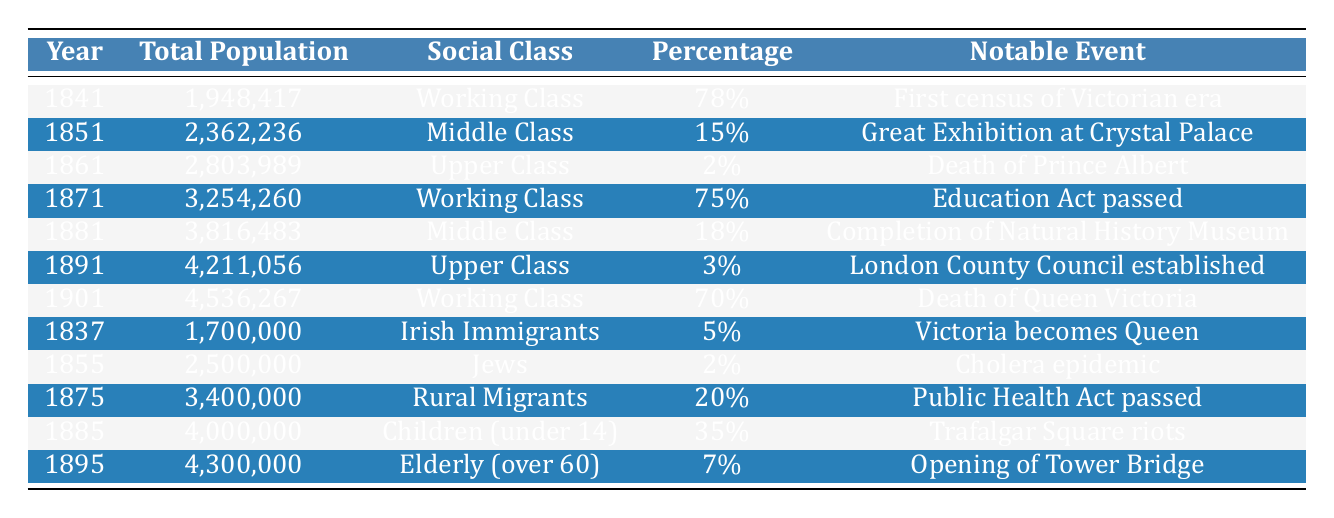What year had the highest total population in London? By inspecting the total population column, the highest value is 4,536,267, which corresponds to the year 1901.
Answer: 1901 What percentage of the population was classified as Working Class in 1841? In 1841, the table indicates that 78% of the population was classified as Working Class.
Answer: 78% What was the total population of London in 1881? The table shows that the total population in 1881 was 3,816,483.
Answer: 3,816,483 Which notable event occurred in the year when the Upper Class made up 2% of the population? In 1861, the Upper Class constituted 2% of the population, and the notable event listed is the death of Prince Albert.
Answer: Death of Prince Albert What was the total population change from 1841 to 1901? The total population increased from 1,948,417 in 1841 to 4,536,267 in 1901. To find the change, subtract the two: 4,536,267 - 1,948,417 = 2,587,850.
Answer: 2,587,850 How many years were there between the passing of the Education Act and the completion of the Natural History Museum? The Education Act was passed in 1871 and the Natural History Museum was completed in 1881. The difference in years is 1881 - 1871 = 10 years.
Answer: 10 years Was the population of Irish Immigrants more than that of Jews in 1855? In 1855, the Jewish population was 2,500,000 while the Irish Immigrant population was listed in 1837 at 1,700,000. Since 1,700,000 is less than 2,500,000, the statement is true.
Answer: Yes What percentage of the population did the Elderly (over 60) represent in 1895? The table indicates that the Elderly represented 7% of the population in 1895.
Answer: 7% What was the total population of Children (under 14) reported in 1885? Referring to the table, the total population of Children (under 14) in 1885 was 4,000,000.
Answer: 4,000,000 Which social class had the lowest percentage in 1891? In 1891, the Upper Class had the lowest percentage recorded, at 3%.
Answer: Upper Class What was the average population of the Working Class across all entries? The Working Class populations in the given years are 1,948,417 (1841), 3,254,260 (1871), and 4,536,267 (1901). To find the average: (1,948,417 + 3,254,260 + 4,536,267) / 3 = 3,246,648. So the average population is approximately 3,246,648.
Answer: 3,246,648 